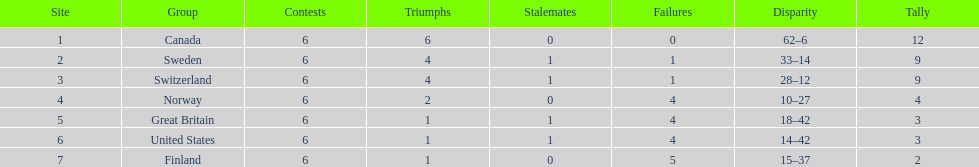How many teams have only one match victory? 3. 